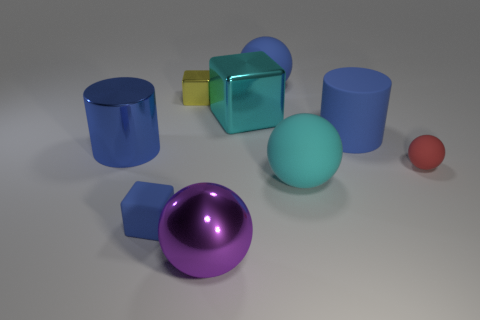Subtract all purple cubes. Subtract all red cylinders. How many cubes are left? 3 Subtract all cyan spheres. How many green blocks are left? 0 Add 5 greens. How many big objects exist? 0 Subtract all tiny yellow objects. Subtract all big red matte cubes. How many objects are left? 8 Add 5 tiny red objects. How many tiny red objects are left? 6 Add 7 large blue rubber objects. How many large blue rubber objects exist? 9 Add 1 green rubber objects. How many objects exist? 10 Subtract all cyan cubes. How many cubes are left? 2 Subtract all large blocks. How many blocks are left? 2 Subtract 1 cyan cubes. How many objects are left? 8 